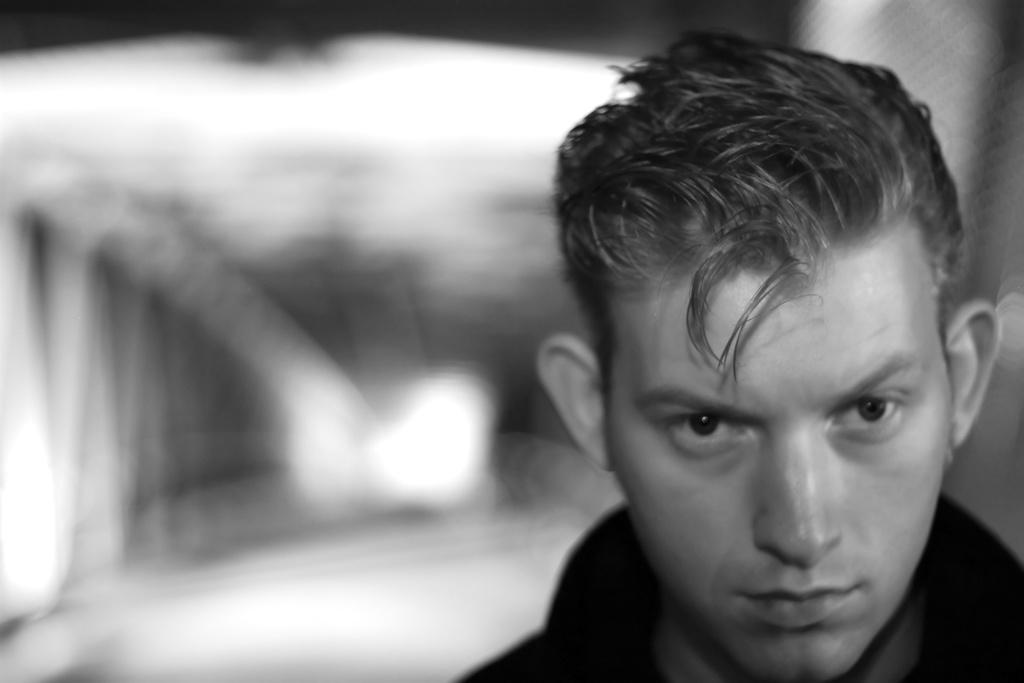What is the main subject of the image? The main subject of the image is a man's face. Where is the man's face located in the image? The man's face is on the right side of the image. What type of stove can be seen in the image? There is no stove present in the image; it features a man's face on the right side. How does the bomb affect the man's face in the image? There is no bomb present in the image, so it cannot affect the man's face. 